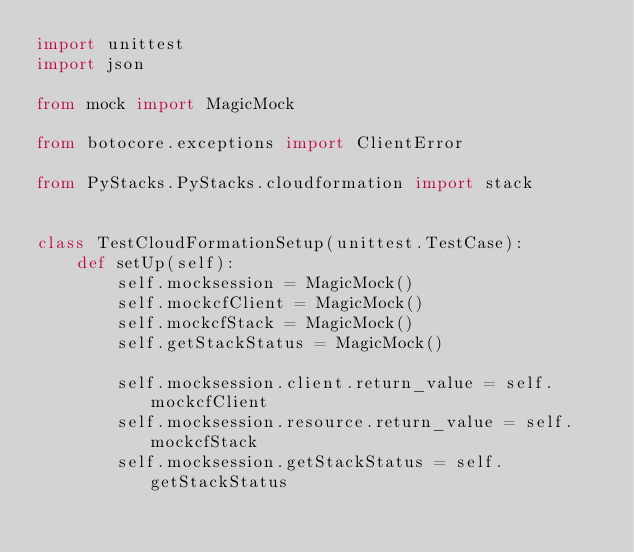Convert code to text. <code><loc_0><loc_0><loc_500><loc_500><_Python_>import unittest
import json

from mock import MagicMock

from botocore.exceptions import ClientError

from PyStacks.PyStacks.cloudformation import stack


class TestCloudFormationSetup(unittest.TestCase):
    def setUp(self):
        self.mocksession = MagicMock()
        self.mockcfClient = MagicMock()
        self.mockcfStack = MagicMock()
        self.getStackStatus = MagicMock()

        self.mocksession.client.return_value = self.mockcfClient
        self.mocksession.resource.return_value = self.mockcfStack
        self.mocksession.getStackStatus = self.getStackStatus
</code> 